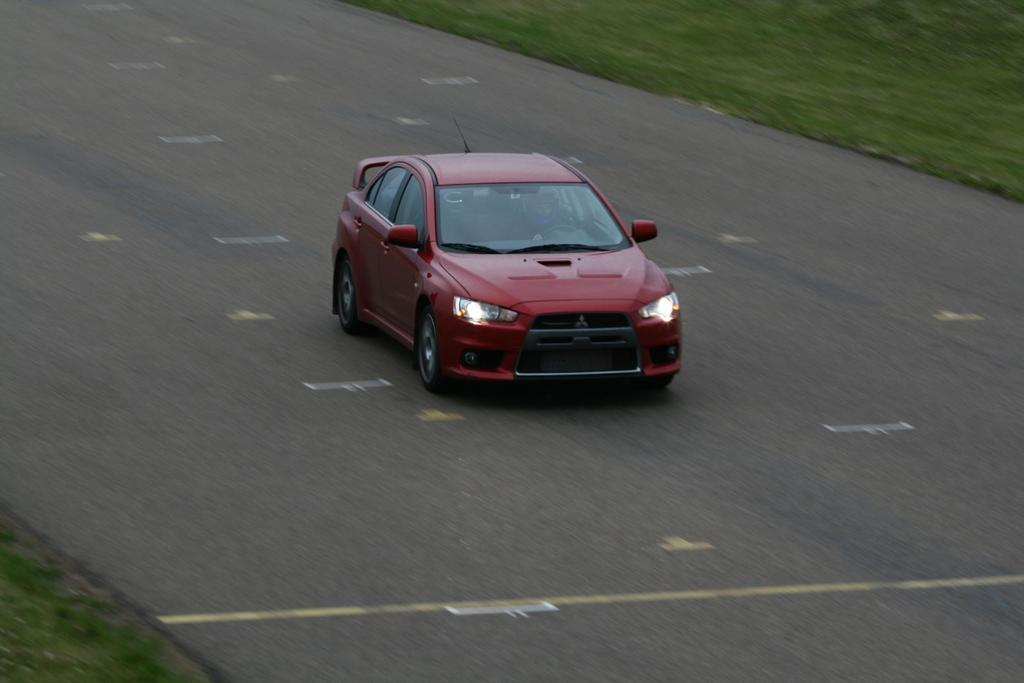What is the main subject of the image? There is a car in the image. Where is the car located? The car is on the road. What type of vegetation can be seen on the ground? There is grass visible on the ground. What type of cork can be seen in the image? There is no cork present in the image. How many quivers are visible in the image? There are no quivers present in the image. 